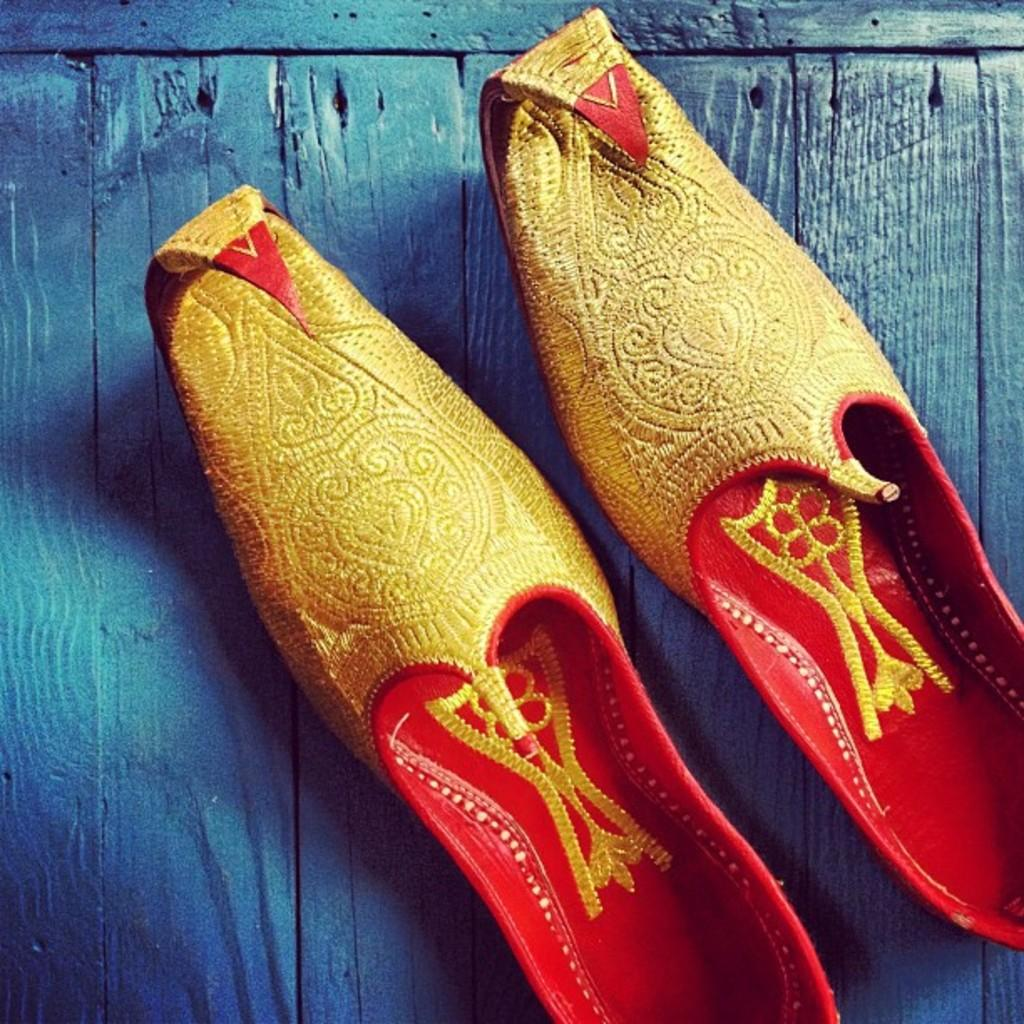What objects are present in the image? There are shoes in the image. Where are the shoes located? The shoes are placed on a wooden table. Is the quicksand visible in the image? There is no quicksand present in the image. What type of string is used to tie the shoes together in the image? There is no string used to tie the shoes together in the image. 